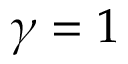<formula> <loc_0><loc_0><loc_500><loc_500>\gamma = 1</formula> 